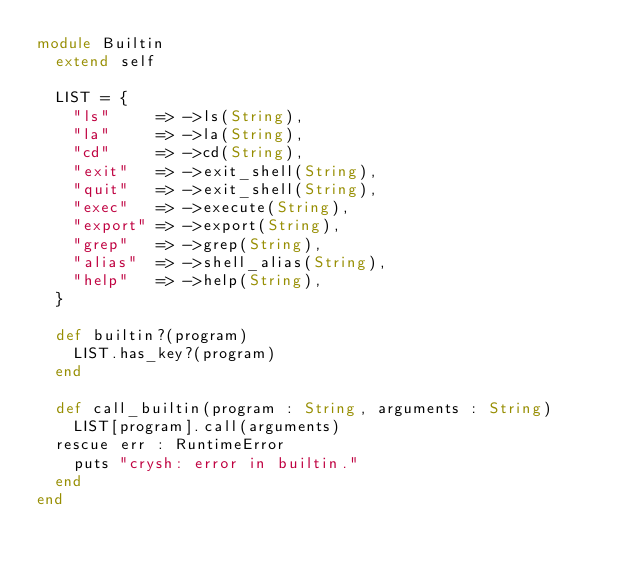Convert code to text. <code><loc_0><loc_0><loc_500><loc_500><_Crystal_>module Builtin
  extend self

  LIST = {
    "ls"     => ->ls(String),
    "la"     => ->la(String),
    "cd"     => ->cd(String),
    "exit"   => ->exit_shell(String),
    "quit"   => ->exit_shell(String),
    "exec"   => ->execute(String),
    "export" => ->export(String),
    "grep"   => ->grep(String),
    "alias"  => ->shell_alias(String),
    "help"   => ->help(String),
  }

  def builtin?(program)
    LIST.has_key?(program)
  end

  def call_builtin(program : String, arguments : String)
    LIST[program].call(arguments)
  rescue err : RuntimeError
    puts "crysh: error in builtin."
  end
end
</code> 